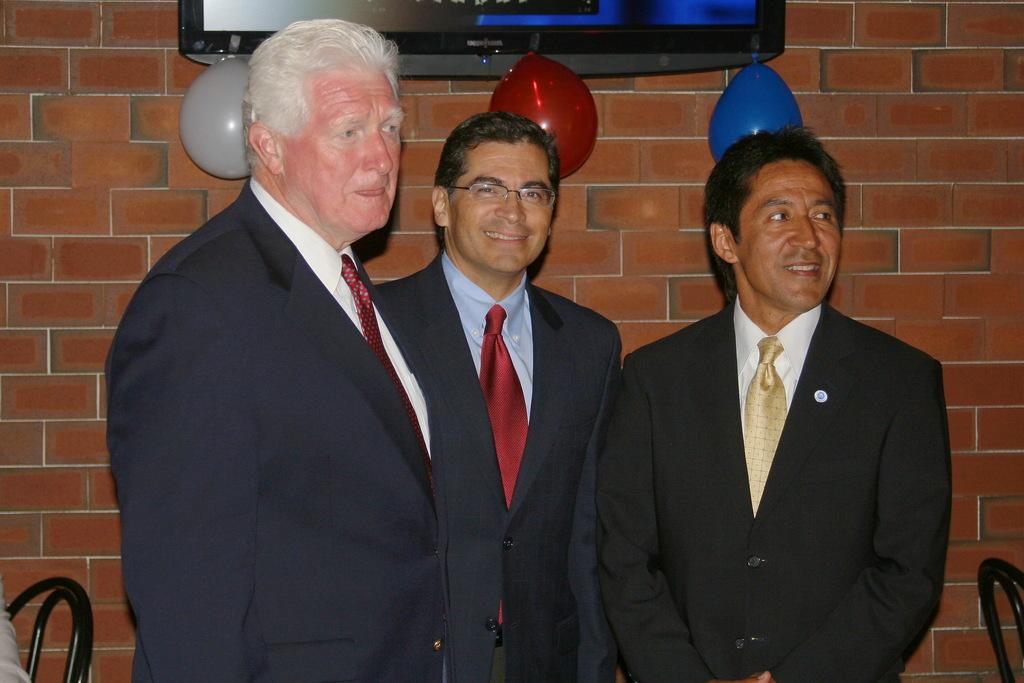How many people are in the image? There are three persons standing in the center of the image. What can be seen in the background of the image? There is a wall, a television, and balloons in the background of the image. Where is the chair located in the image? The chair is in the bottom left corner of the image. What type of mint is growing on the wall in the image? There is no mint plant present in the image; the wall is a background element without any visible plants. 